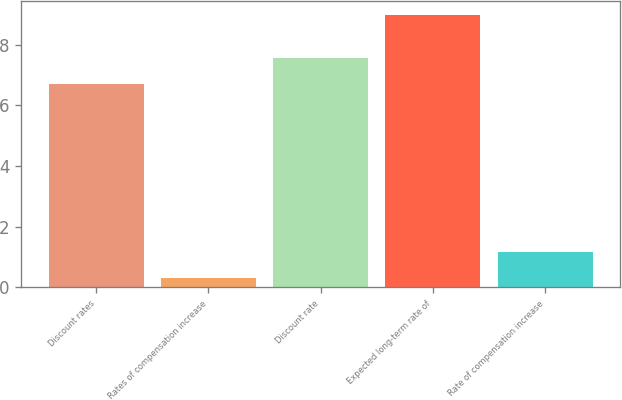Convert chart to OTSL. <chart><loc_0><loc_0><loc_500><loc_500><bar_chart><fcel>Discount rates<fcel>Rates of compensation increase<fcel>Discount rate<fcel>Expected long-term rate of<fcel>Rate of compensation increase<nl><fcel>6.7<fcel>0.3<fcel>7.57<fcel>9<fcel>1.17<nl></chart> 